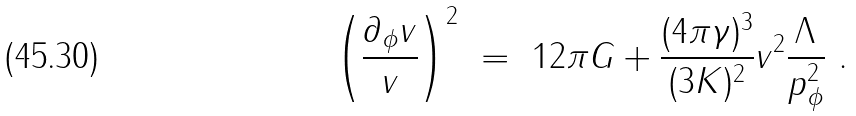Convert formula to latex. <formula><loc_0><loc_0><loc_500><loc_500>\left ( \frac { \partial _ { \phi } v } { v } \right ) ^ { 2 } \ = \ 1 2 \pi G + \frac { ( 4 \pi \gamma ) ^ { 3 } } { ( 3 K ) ^ { 2 } } v ^ { 2 } \frac { \Lambda } { p ^ { 2 } _ { \phi } } \ .</formula> 